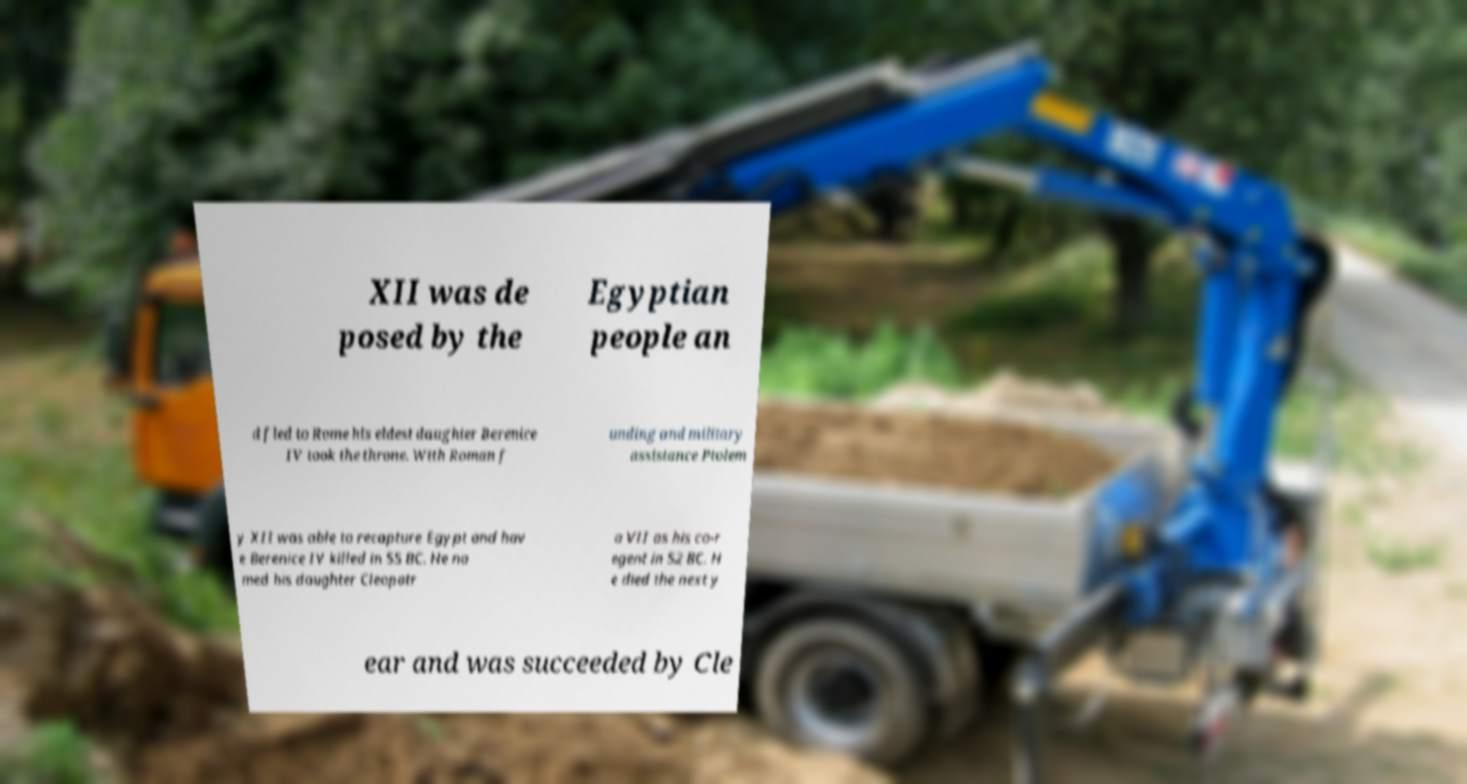Could you assist in decoding the text presented in this image and type it out clearly? XII was de posed by the Egyptian people an d fled to Rome his eldest daughter Berenice IV took the throne. With Roman f unding and military assistance Ptolem y XII was able to recapture Egypt and hav e Berenice IV killed in 55 BC. He na med his daughter Cleopatr a VII as his co-r egent in 52 BC. H e died the next y ear and was succeeded by Cle 